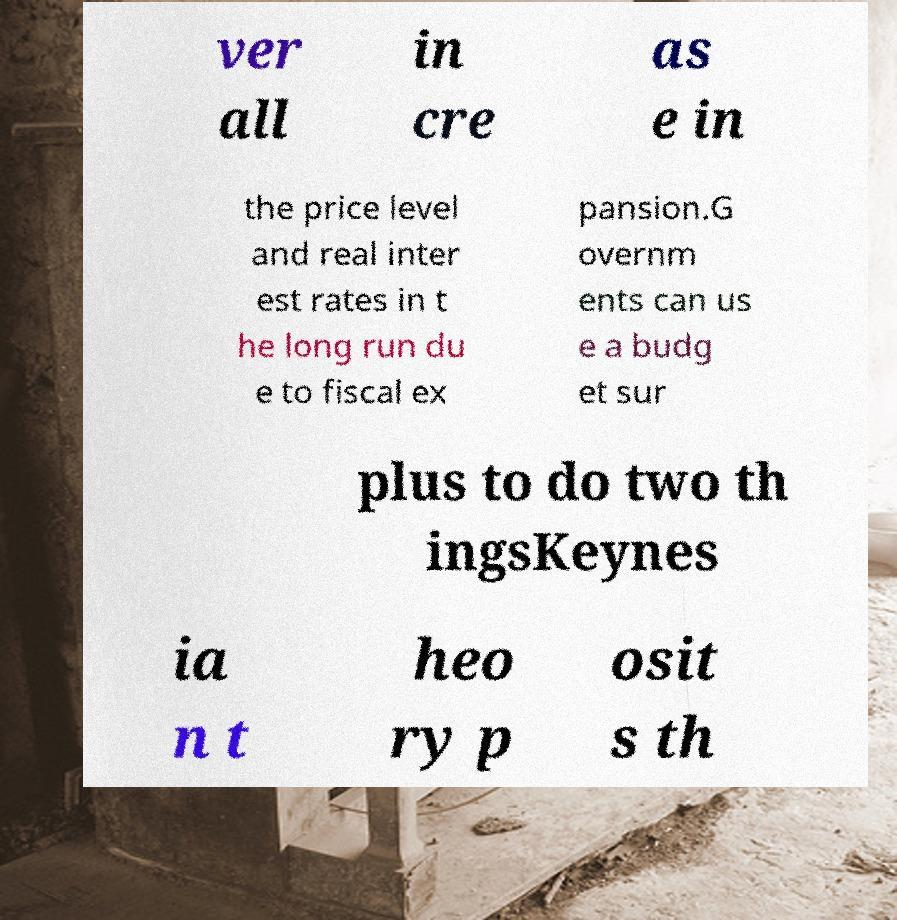Can you read and provide the text displayed in the image?This photo seems to have some interesting text. Can you extract and type it out for me? ver all in cre as e in the price level and real inter est rates in t he long run du e to fiscal ex pansion.G overnm ents can us e a budg et sur plus to do two th ingsKeynes ia n t heo ry p osit s th 